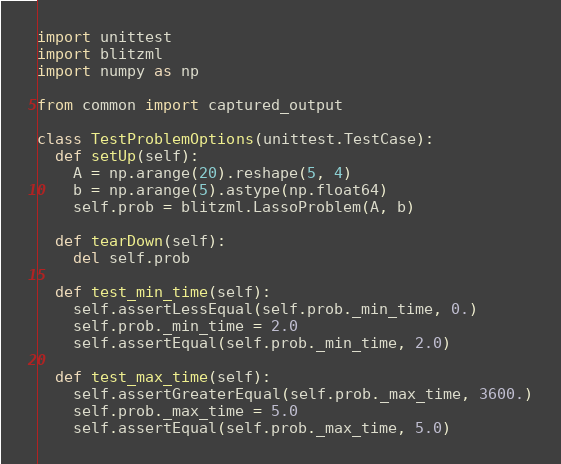<code> <loc_0><loc_0><loc_500><loc_500><_Python_>import unittest
import blitzml
import numpy as np

from common import captured_output

class TestProblemOptions(unittest.TestCase):
  def setUp(self):
    A = np.arange(20).reshape(5, 4)
    b = np.arange(5).astype(np.float64)
    self.prob = blitzml.LassoProblem(A, b)

  def tearDown(self):
    del self.prob

  def test_min_time(self):
    self.assertLessEqual(self.prob._min_time, 0.)
    self.prob._min_time = 2.0
    self.assertEqual(self.prob._min_time, 2.0)

  def test_max_time(self):
    self.assertGreaterEqual(self.prob._max_time, 3600.)
    self.prob._max_time = 5.0
    self.assertEqual(self.prob._max_time, 5.0)
</code> 